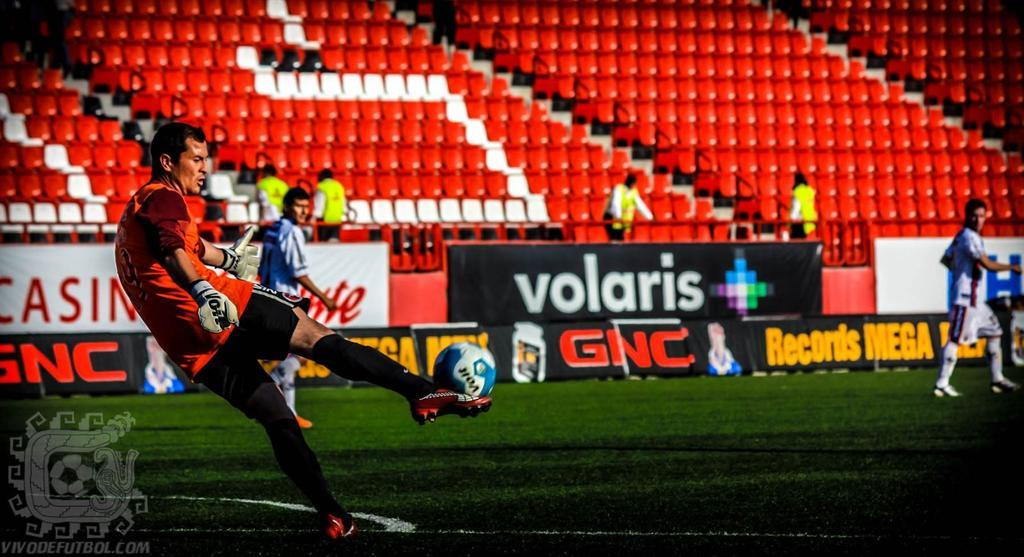<image>
Relay a brief, clear account of the picture shown. Athletes playing on a field sponsored by Volaris and GNC. 